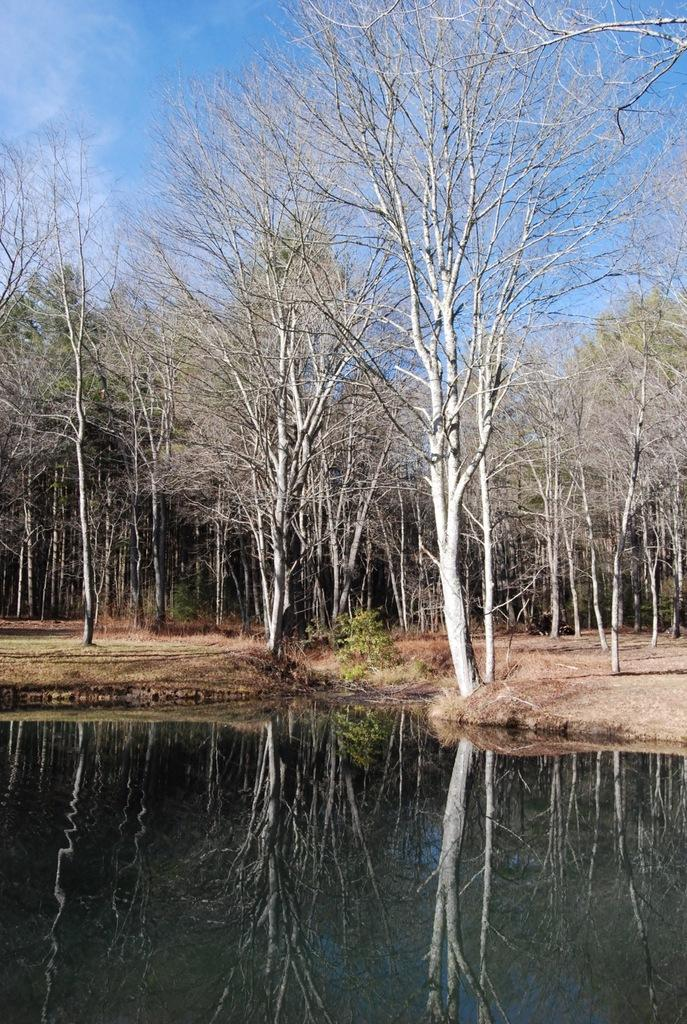What is present in the front of the image? There is water in the front of the image. What can be seen in the background of the image? There are trees and clouds in the background of the image. What is visible in the sky in the image? The sky is visible in the background of the image. What is reflected on the water in the image? There is a reflection of trees on the water. Can you see any nails sticking out of the trees in the image? There are no nails visible in the image; it features water, trees, clouds, and a sky reflection. Is there a farm visible in the image? There is no farm present in the image. 